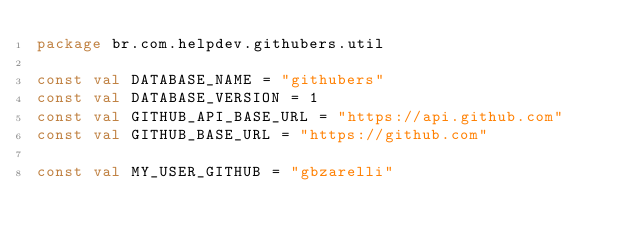Convert code to text. <code><loc_0><loc_0><loc_500><loc_500><_Kotlin_>package br.com.helpdev.githubers.util

const val DATABASE_NAME = "githubers"
const val DATABASE_VERSION = 1
const val GITHUB_API_BASE_URL = "https://api.github.com"
const val GITHUB_BASE_URL = "https://github.com"

const val MY_USER_GITHUB = "gbzarelli"
</code> 